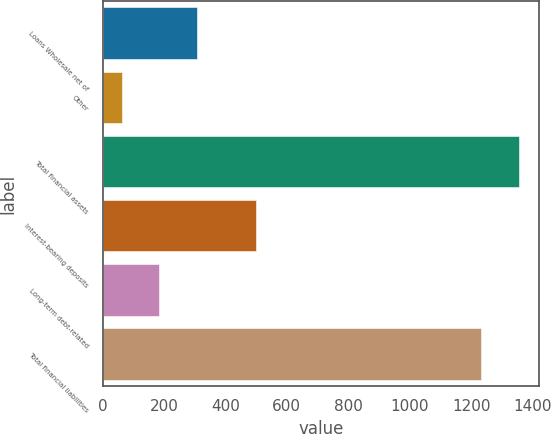Convert chart. <chart><loc_0><loc_0><loc_500><loc_500><bar_chart><fcel>Loans Wholesale net of<fcel>Other<fcel>Total financial assets<fcel>Interest-bearing deposits<fcel>Long-term debt-related<fcel>Total financial liabilities<nl><fcel>308.02<fcel>62.4<fcel>1354.61<fcel>498.4<fcel>185.21<fcel>1231.8<nl></chart> 